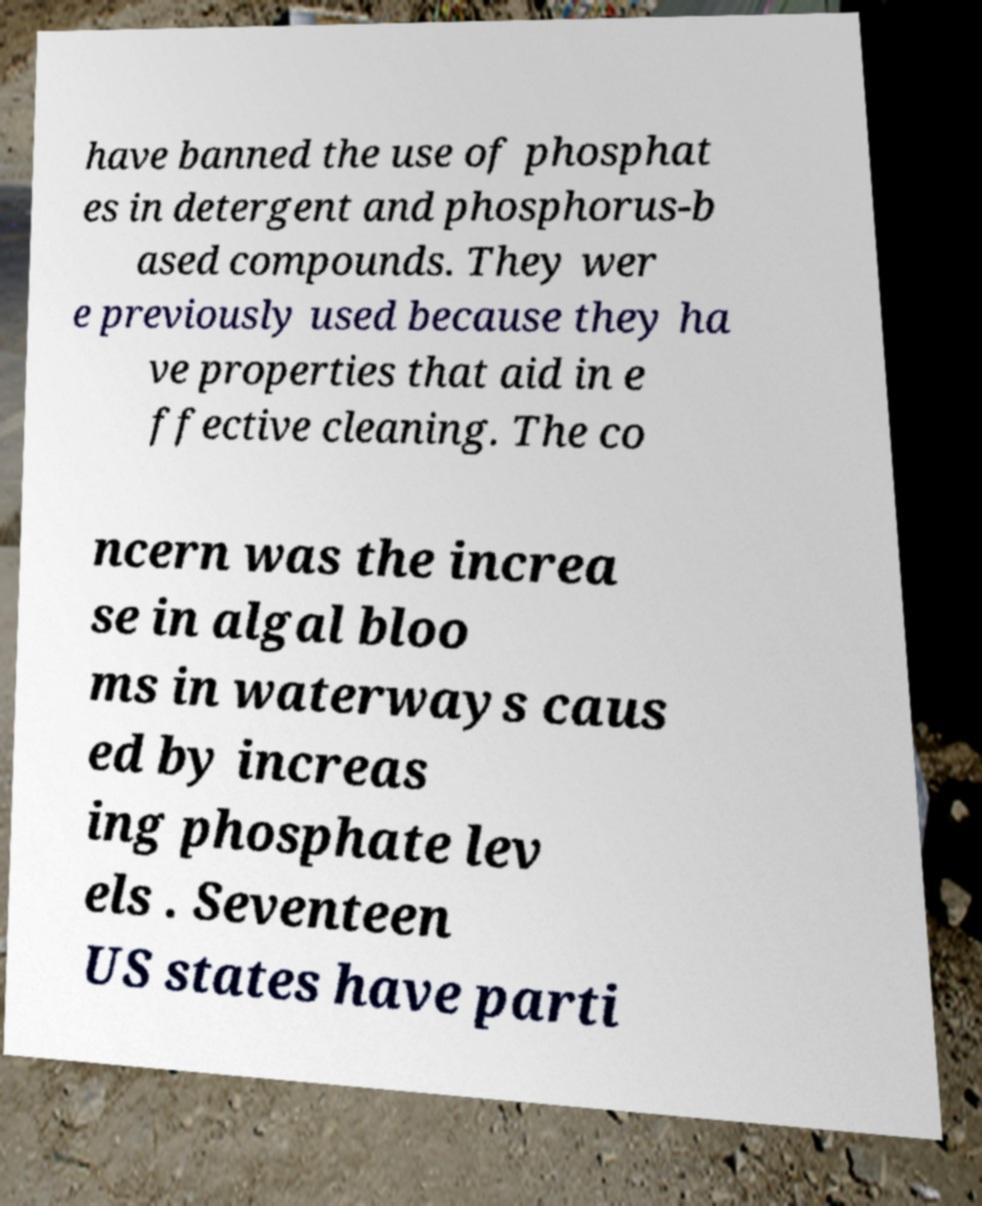There's text embedded in this image that I need extracted. Can you transcribe it verbatim? have banned the use of phosphat es in detergent and phosphorus-b ased compounds. They wer e previously used because they ha ve properties that aid in e ffective cleaning. The co ncern was the increa se in algal bloo ms in waterways caus ed by increas ing phosphate lev els . Seventeen US states have parti 